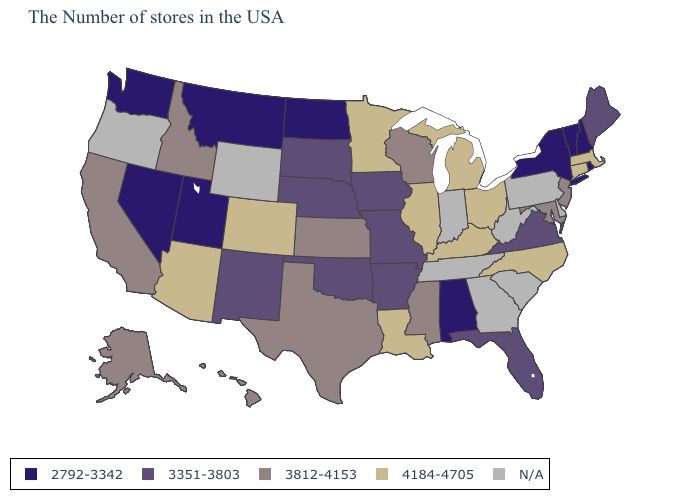What is the highest value in the MidWest ?
Quick response, please. 4184-4705. Does Minnesota have the highest value in the USA?
Answer briefly. Yes. Which states have the lowest value in the USA?
Answer briefly. Rhode Island, New Hampshire, Vermont, New York, Alabama, North Dakota, Utah, Montana, Nevada, Washington. Is the legend a continuous bar?
Write a very short answer. No. Name the states that have a value in the range 3812-4153?
Be succinct. New Jersey, Maryland, Wisconsin, Mississippi, Kansas, Texas, Idaho, California, Alaska, Hawaii. What is the value of Delaware?
Be succinct. N/A. Does the map have missing data?
Answer briefly. Yes. Name the states that have a value in the range N/A?
Quick response, please. Delaware, Pennsylvania, South Carolina, West Virginia, Georgia, Indiana, Tennessee, Wyoming, Oregon. What is the value of New Hampshire?
Write a very short answer. 2792-3342. Among the states that border Rhode Island , which have the lowest value?
Short answer required. Massachusetts, Connecticut. Name the states that have a value in the range 3351-3803?
Write a very short answer. Maine, Virginia, Florida, Missouri, Arkansas, Iowa, Nebraska, Oklahoma, South Dakota, New Mexico. Name the states that have a value in the range 2792-3342?
Concise answer only. Rhode Island, New Hampshire, Vermont, New York, Alabama, North Dakota, Utah, Montana, Nevada, Washington. Name the states that have a value in the range 3812-4153?
Write a very short answer. New Jersey, Maryland, Wisconsin, Mississippi, Kansas, Texas, Idaho, California, Alaska, Hawaii. Does North Dakota have the lowest value in the MidWest?
Answer briefly. Yes. What is the highest value in the Northeast ?
Short answer required. 4184-4705. 